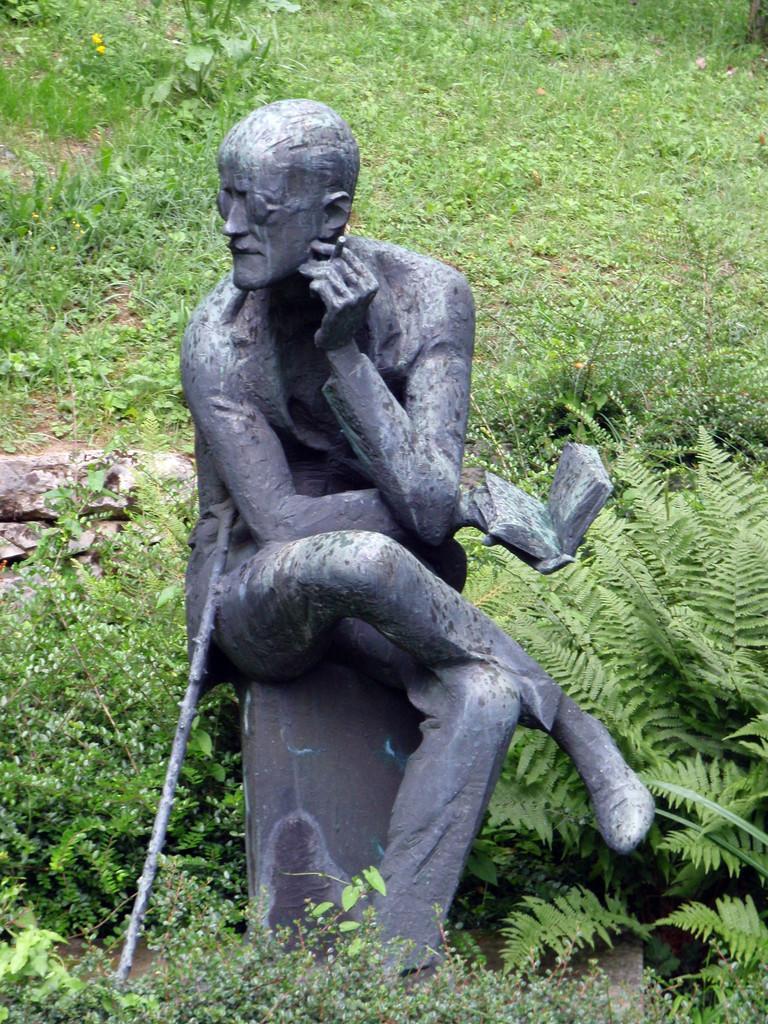Describe this image in one or two sentences. There is a person's statue, sitting on a pole, holding a book with one hand and an object with other hand on the ground, near plants. And there is a stick leaning on his leg. In the background, there is grass and there are plants. 